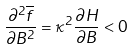<formula> <loc_0><loc_0><loc_500><loc_500>\frac { \partial ^ { 2 } \overline { f } } { \partial B ^ { 2 } } = \kappa ^ { 2 } \frac { \partial H } { \partial B } < 0</formula> 